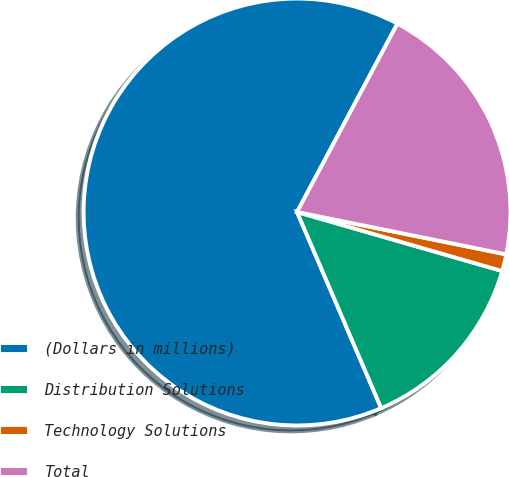Convert chart to OTSL. <chart><loc_0><loc_0><loc_500><loc_500><pie_chart><fcel>(Dollars in millions)<fcel>Distribution Solutions<fcel>Technology Solutions<fcel>Total<nl><fcel>64.24%<fcel>14.09%<fcel>1.28%<fcel>20.39%<nl></chart> 